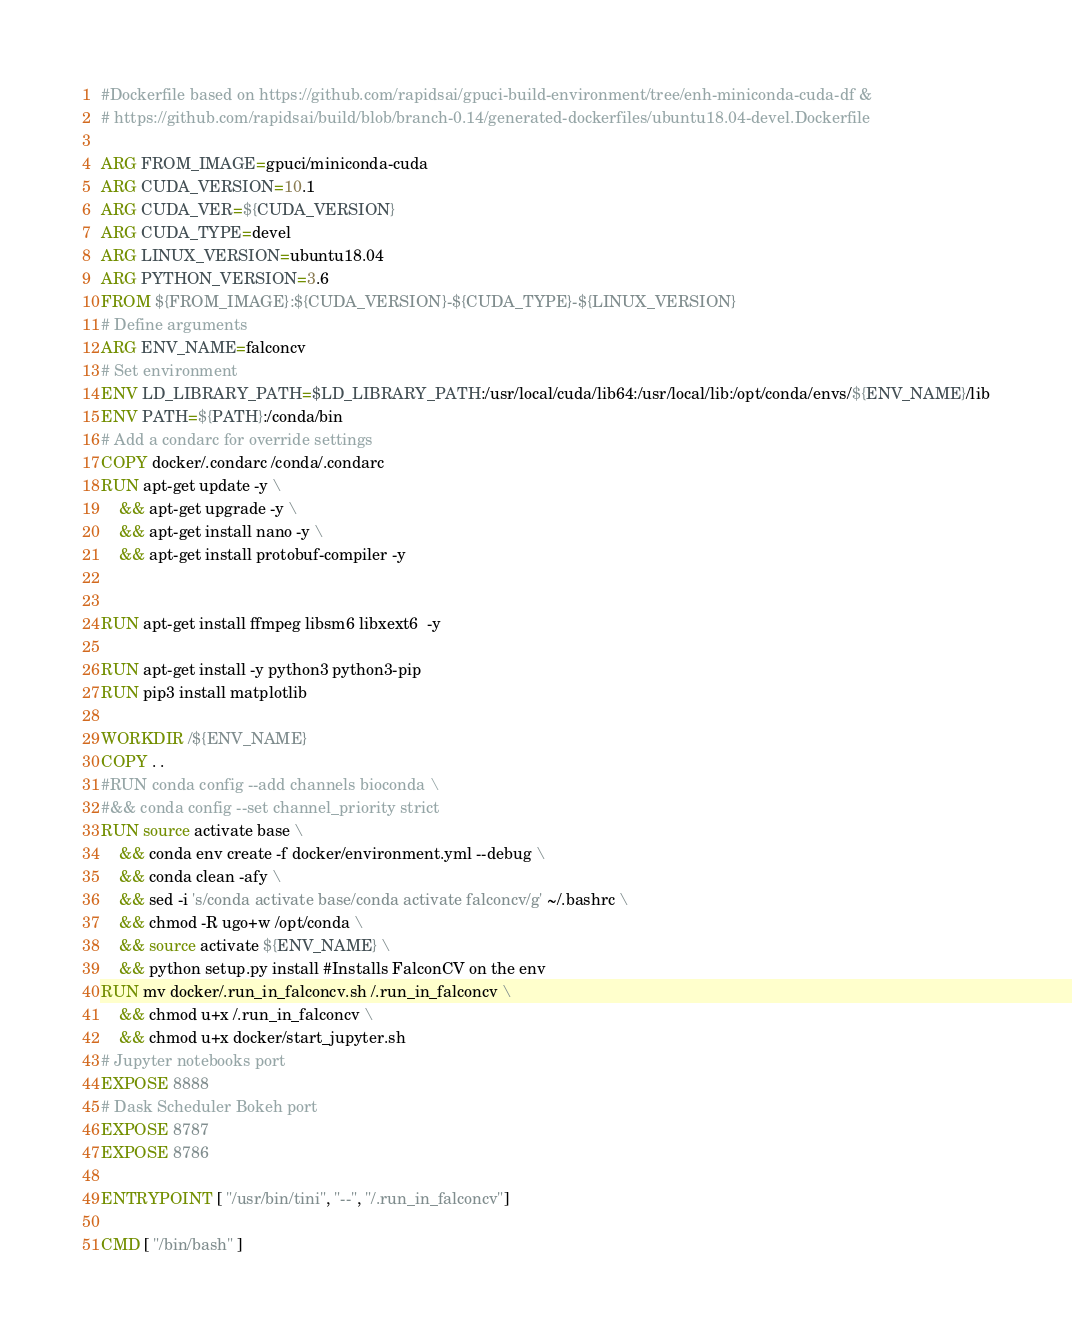<code> <loc_0><loc_0><loc_500><loc_500><_Dockerfile_>#Dockerfile based on https://github.com/rapidsai/gpuci-build-environment/tree/enh-miniconda-cuda-df &
# https://github.com/rapidsai/build/blob/branch-0.14/generated-dockerfiles/ubuntu18.04-devel.Dockerfile

ARG FROM_IMAGE=gpuci/miniconda-cuda
ARG CUDA_VERSION=10.1
ARG CUDA_VER=${CUDA_VERSION}
ARG CUDA_TYPE=devel
ARG LINUX_VERSION=ubuntu18.04
ARG PYTHON_VERSION=3.6
FROM ${FROM_IMAGE}:${CUDA_VERSION}-${CUDA_TYPE}-${LINUX_VERSION}
# Define arguments
ARG ENV_NAME=falconcv
# Set environment
ENV LD_LIBRARY_PATH=$LD_LIBRARY_PATH:/usr/local/cuda/lib64:/usr/local/lib:/opt/conda/envs/${ENV_NAME}/lib
ENV PATH=${PATH}:/conda/bin
# Add a condarc for override settings
COPY docker/.condarc /conda/.condarc
RUN apt-get update -y \
    && apt-get upgrade -y \
    && apt-get install nano -y \
    && apt-get install protobuf-compiler -y


RUN apt-get install ffmpeg libsm6 libxext6  -y

RUN apt-get install -y python3 python3-pip
RUN pip3 install matplotlib

WORKDIR /${ENV_NAME}
COPY . .
#RUN conda config --add channels bioconda \
#&& conda config --set channel_priority strict
RUN source activate base \
    && conda env create -f docker/environment.yml --debug \
    && conda clean -afy \
    && sed -i 's/conda activate base/conda activate falconcv/g' ~/.bashrc \
    && chmod -R ugo+w /opt/conda \
    && source activate ${ENV_NAME} \
    && python setup.py install #Installs FalconCV on the env
RUN mv docker/.run_in_falconcv.sh /.run_in_falconcv \
    && chmod u+x /.run_in_falconcv \
    && chmod u+x docker/start_jupyter.sh
# Jupyter notebooks port
EXPOSE 8888
# Dask Scheduler Bokeh port
EXPOSE 8787
EXPOSE 8786

ENTRYPOINT [ "/usr/bin/tini", "--", "/.run_in_falconcv"]

CMD [ "/bin/bash" ]</code> 